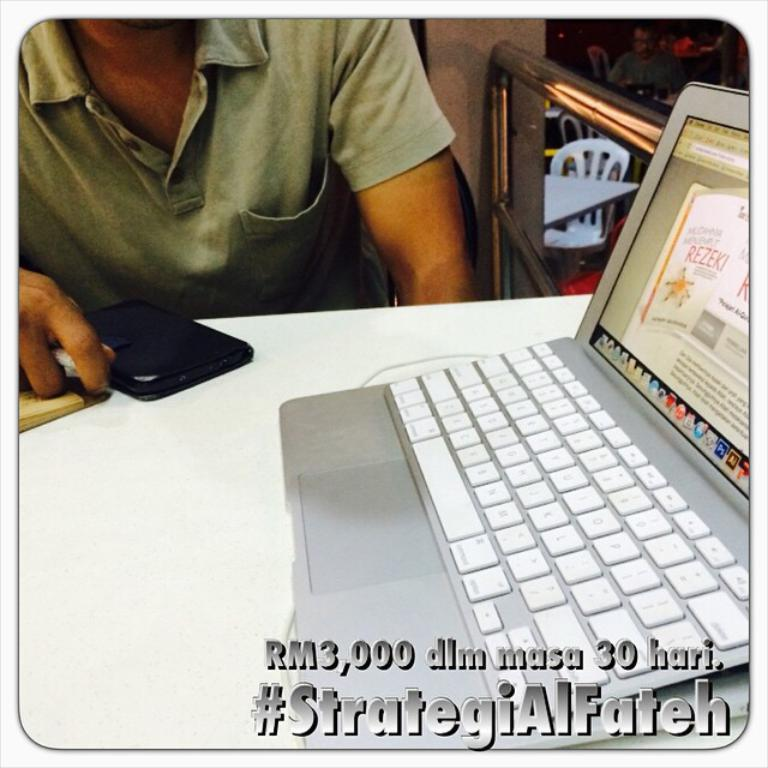<image>
Relay a brief, clear account of the picture shown. An open laptop on a table witha man sitting nearby captioned with the hashtag StrategiAlFateh. 